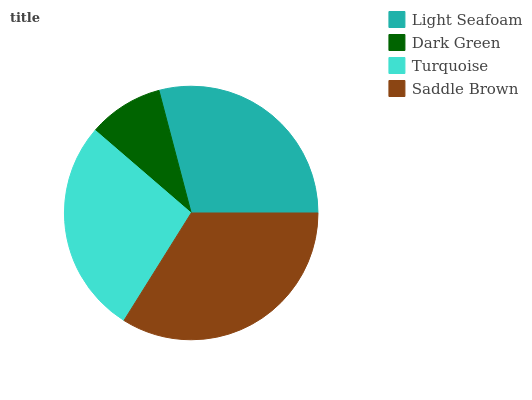Is Dark Green the minimum?
Answer yes or no. Yes. Is Saddle Brown the maximum?
Answer yes or no. Yes. Is Turquoise the minimum?
Answer yes or no. No. Is Turquoise the maximum?
Answer yes or no. No. Is Turquoise greater than Dark Green?
Answer yes or no. Yes. Is Dark Green less than Turquoise?
Answer yes or no. Yes. Is Dark Green greater than Turquoise?
Answer yes or no. No. Is Turquoise less than Dark Green?
Answer yes or no. No. Is Light Seafoam the high median?
Answer yes or no. Yes. Is Turquoise the low median?
Answer yes or no. Yes. Is Turquoise the high median?
Answer yes or no. No. Is Saddle Brown the low median?
Answer yes or no. No. 